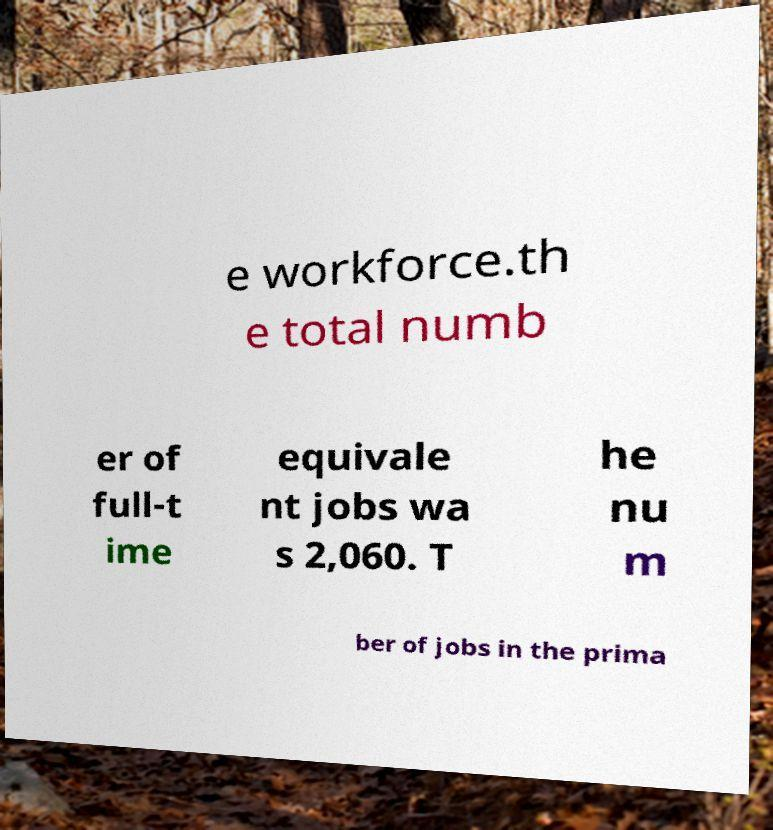Can you read and provide the text displayed in the image?This photo seems to have some interesting text. Can you extract and type it out for me? e workforce.th e total numb er of full-t ime equivale nt jobs wa s 2,060. T he nu m ber of jobs in the prima 